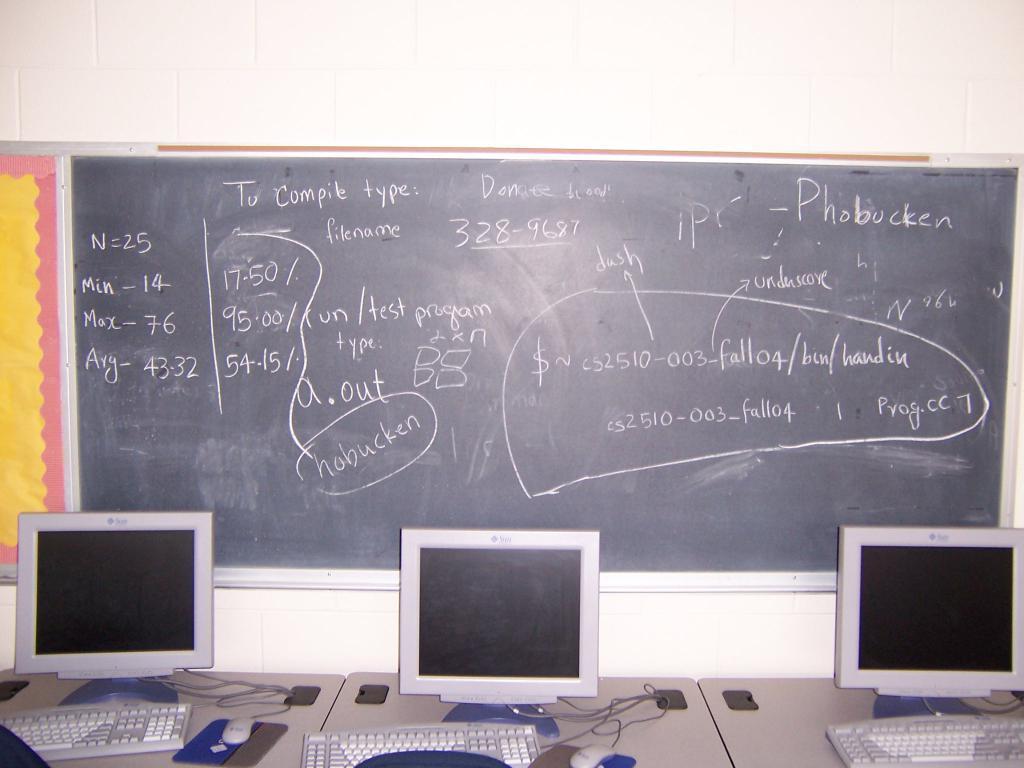Could you give a brief overview of what you see in this image? As we can see in the image there are white color tiles, board and tables. On tables there are keyboards, mouses and screens. 